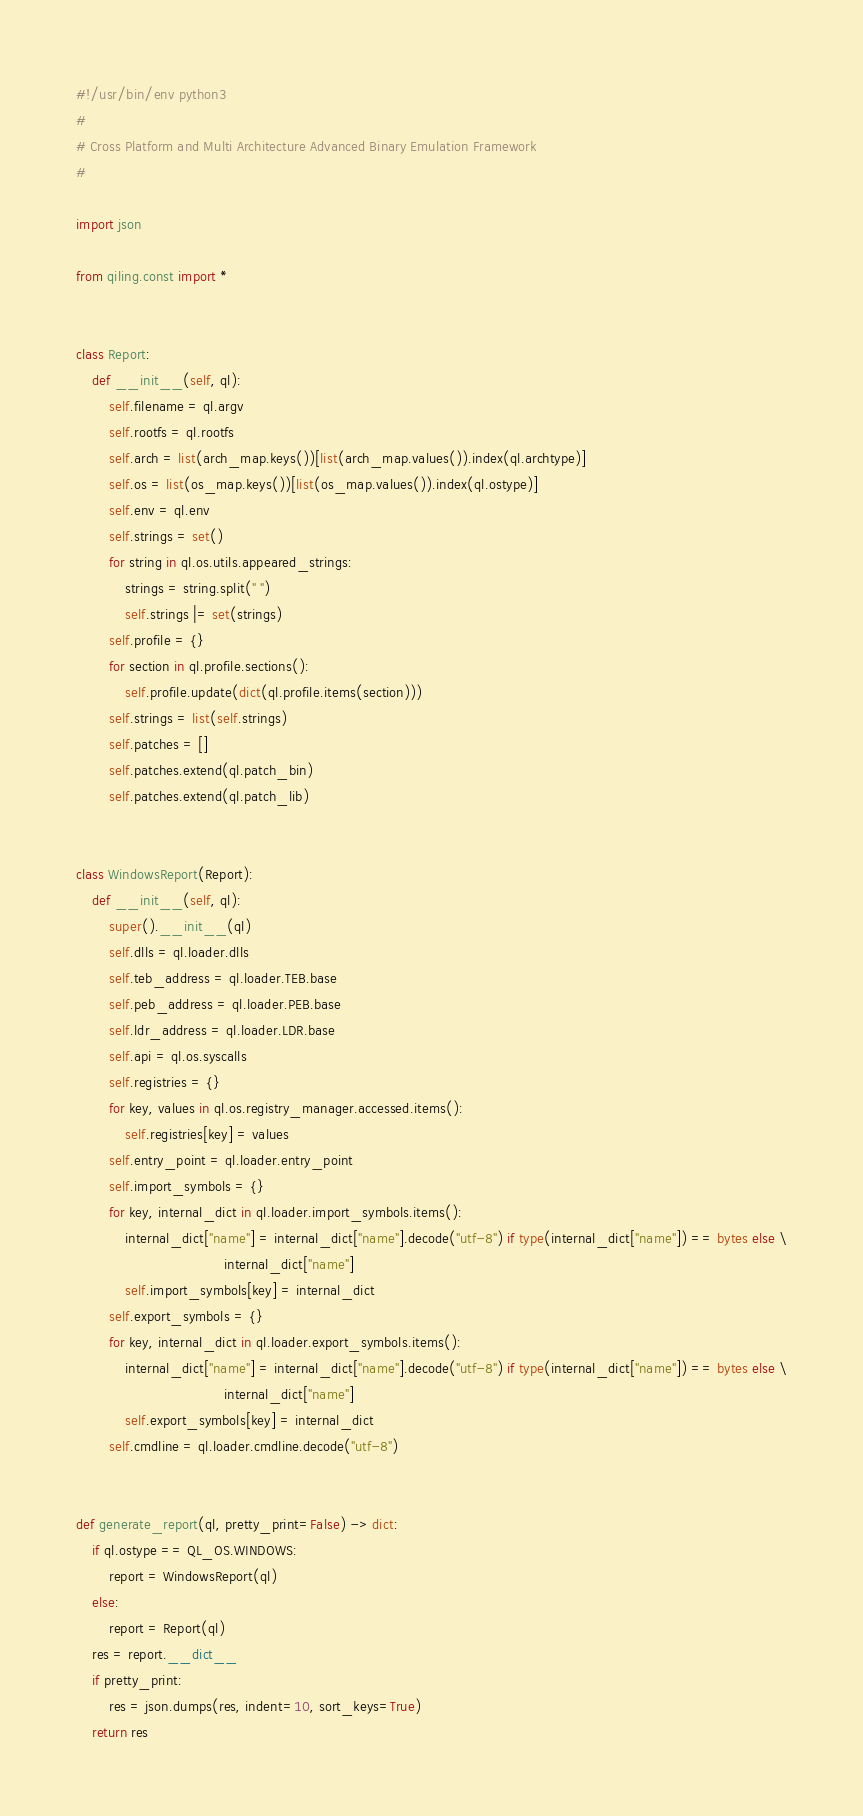<code> <loc_0><loc_0><loc_500><loc_500><_Python_>#!/usr/bin/env python3
# 
# Cross Platform and Multi Architecture Advanced Binary Emulation Framework
#

import json

from qiling.const import *


class Report:
    def __init__(self, ql):
        self.filename = ql.argv
        self.rootfs = ql.rootfs
        self.arch = list(arch_map.keys())[list(arch_map.values()).index(ql.archtype)]
        self.os = list(os_map.keys())[list(os_map.values()).index(ql.ostype)]
        self.env = ql.env
        self.strings = set()
        for string in ql.os.utils.appeared_strings:
            strings = string.split(" ")
            self.strings |= set(strings)
        self.profile = {}
        for section in ql.profile.sections():
            self.profile.update(dict(ql.profile.items(section)))
        self.strings = list(self.strings)
        self.patches = []
        self.patches.extend(ql.patch_bin)
        self.patches.extend(ql.patch_lib)


class WindowsReport(Report):
    def __init__(self, ql):
        super().__init__(ql)
        self.dlls = ql.loader.dlls
        self.teb_address = ql.loader.TEB.base
        self.peb_address = ql.loader.PEB.base
        self.ldr_address = ql.loader.LDR.base
        self.api = ql.os.syscalls
        self.registries = {}
        for key, values in ql.os.registry_manager.accessed.items():
            self.registries[key] = values
        self.entry_point = ql.loader.entry_point
        self.import_symbols = {}
        for key, internal_dict in ql.loader.import_symbols.items():
            internal_dict["name"] = internal_dict["name"].decode("utf-8") if type(internal_dict["name"]) == bytes else \
                                    internal_dict["name"]
            self.import_symbols[key] = internal_dict
        self.export_symbols = {}
        for key, internal_dict in ql.loader.export_symbols.items():
            internal_dict["name"] = internal_dict["name"].decode("utf-8") if type(internal_dict["name"]) == bytes else \
                                    internal_dict["name"]
            self.export_symbols[key] = internal_dict
        self.cmdline = ql.loader.cmdline.decode("utf-8")


def generate_report(ql, pretty_print=False) -> dict:
    if ql.ostype == QL_OS.WINDOWS:
        report = WindowsReport(ql)
    else:
        report = Report(ql)
    res = report.__dict__
    if pretty_print:
        res = json.dumps(res, indent=10, sort_keys=True)
    return res
</code> 